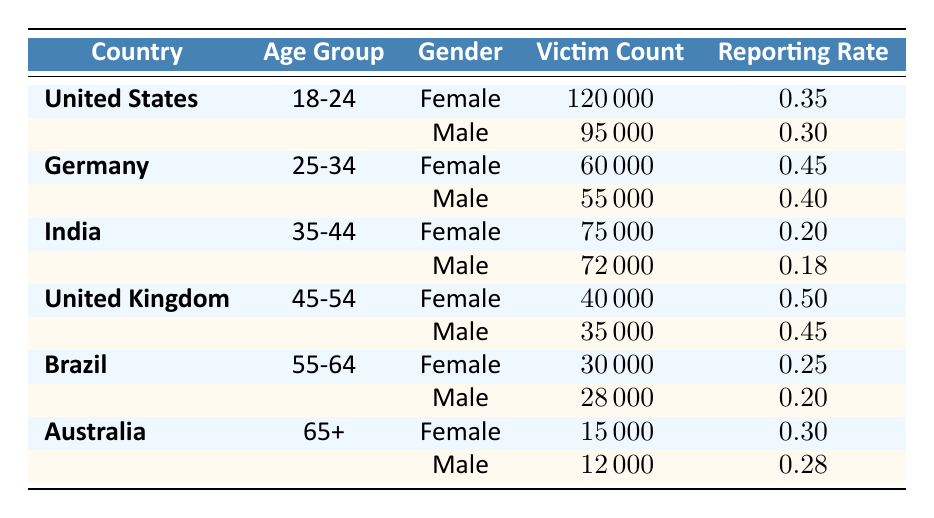What is the reporting rate for female victims in the United States aged 18-24? The table shows that the reporting rate for female victims in the United States aged 18-24 is 0.35.
Answer: 0.35 Which country has the highest number of male victims in the 18-24 age group? According to the table, the United States has the highest number of male victims in the 18-24 age group with a victim count of 95,000.
Answer: United States What is the victim count for female victims aged 35-44 in India? The victim count for female victims aged 35-44 in India is directly listed in the table as 75,000.
Answer: 75000 How many male victims were reported in Germany? In Germany, the male victim count is 55,000, so to get the total male victims, we directly refer to the male row entries (55,000).
Answer: 55,000 What is the average reporting rate for all countries for the male age group aged 55-64? The average reporting rate for male victims aged 55-64 in Brazil is 0.20, which is listed in the table (only Brazil has data for this age group). Since no other countries are listed for this age group, the average is simply 0.20.
Answer: 0.20 Are there more victims for male or female in the 45-54 age group in the United Kingdom? For the United Kingdom, the male victim count in the 45-54 age group is 35,000 and the female victim count is 40,000. Since 40,000 is greater than 35,000, there are more female victims.
Answer: Yes What is the total number of victims for all age groups in Australia? To find the total number of victims in Australia, we sum the counts for both genders in the 65+ age group: 15,000 (Female) + 12,000 (Male) = 27,000.
Answer: 27000 Which age group has the lowest reporting rate among male victims across all countries? Examining the table, the lowest reporting rate among male victims is in India for the 35-44 age group at 0.18.
Answer: 0.18 What is the difference in victim counts between the highest and lowest male victim count in the table? The highest male victim count is in the United States with 95,000, and the lowest is in Australia with 12,000. The difference is 95,000 - 12,000 = 83,000.
Answer: 83000 How many total victims were reported across all female age groups in Germany? In Germany, the female victim counts are 60,000 (25-34 age group). Since only one data point exists, the total count for females there is simply 60,000.
Answer: 60000 